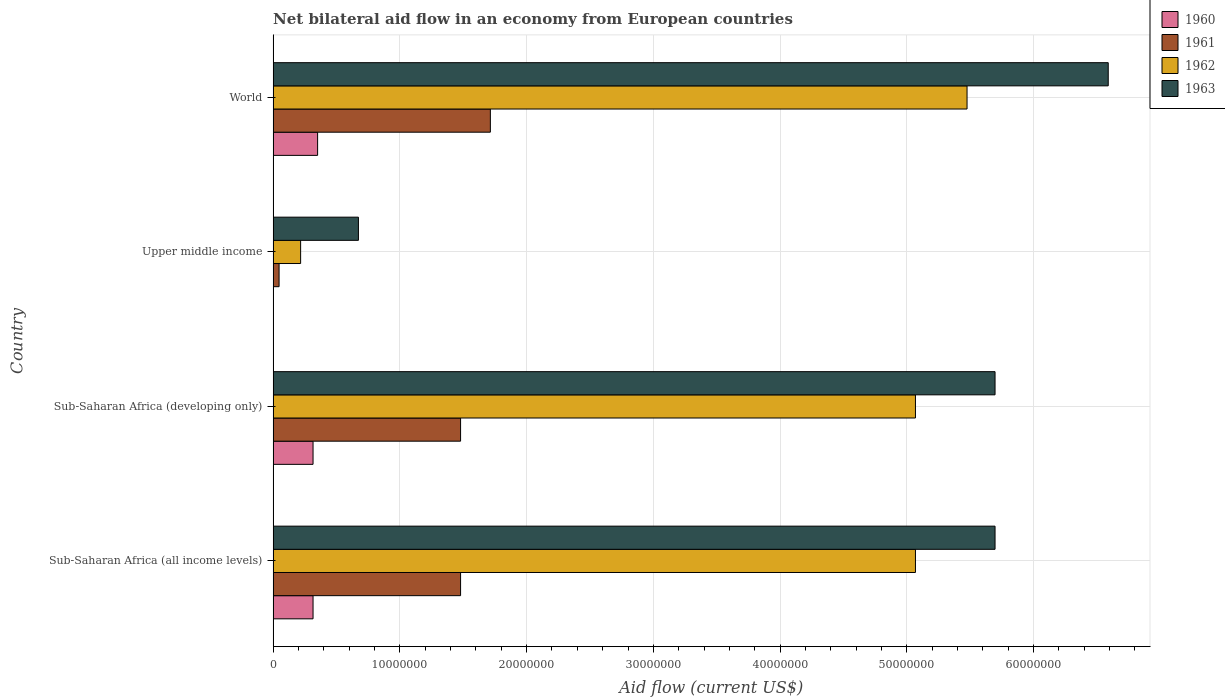How many different coloured bars are there?
Give a very brief answer. 4. How many groups of bars are there?
Give a very brief answer. 4. Are the number of bars per tick equal to the number of legend labels?
Provide a short and direct response. Yes. Are the number of bars on each tick of the Y-axis equal?
Offer a terse response. Yes. How many bars are there on the 4th tick from the top?
Offer a very short reply. 4. How many bars are there on the 4th tick from the bottom?
Ensure brevity in your answer.  4. What is the label of the 3rd group of bars from the top?
Provide a short and direct response. Sub-Saharan Africa (developing only). What is the net bilateral aid flow in 1962 in World?
Provide a succinct answer. 5.48e+07. Across all countries, what is the maximum net bilateral aid flow in 1960?
Your answer should be compact. 3.51e+06. In which country was the net bilateral aid flow in 1960 maximum?
Keep it short and to the point. World. In which country was the net bilateral aid flow in 1962 minimum?
Your answer should be compact. Upper middle income. What is the total net bilateral aid flow in 1961 in the graph?
Provide a succinct answer. 4.72e+07. What is the difference between the net bilateral aid flow in 1961 in Sub-Saharan Africa (all income levels) and that in Upper middle income?
Make the answer very short. 1.43e+07. What is the difference between the net bilateral aid flow in 1963 in Sub-Saharan Africa (developing only) and the net bilateral aid flow in 1962 in Upper middle income?
Your answer should be very brief. 5.48e+07. What is the average net bilateral aid flow in 1960 per country?
Keep it short and to the point. 2.46e+06. What is the difference between the net bilateral aid flow in 1960 and net bilateral aid flow in 1962 in World?
Ensure brevity in your answer.  -5.12e+07. In how many countries, is the net bilateral aid flow in 1961 greater than 24000000 US$?
Ensure brevity in your answer.  0. What is the ratio of the net bilateral aid flow in 1961 in Sub-Saharan Africa (developing only) to that in World?
Make the answer very short. 0.86. Is the difference between the net bilateral aid flow in 1960 in Sub-Saharan Africa (developing only) and World greater than the difference between the net bilateral aid flow in 1962 in Sub-Saharan Africa (developing only) and World?
Ensure brevity in your answer.  Yes. What is the difference between the highest and the second highest net bilateral aid flow in 1961?
Ensure brevity in your answer.  2.35e+06. What is the difference between the highest and the lowest net bilateral aid flow in 1962?
Your answer should be very brief. 5.26e+07. In how many countries, is the net bilateral aid flow in 1963 greater than the average net bilateral aid flow in 1963 taken over all countries?
Your answer should be compact. 3. Is it the case that in every country, the sum of the net bilateral aid flow in 1960 and net bilateral aid flow in 1963 is greater than the sum of net bilateral aid flow in 1961 and net bilateral aid flow in 1962?
Your answer should be very brief. No. What does the 2nd bar from the top in World represents?
Your response must be concise. 1962. Is it the case that in every country, the sum of the net bilateral aid flow in 1962 and net bilateral aid flow in 1963 is greater than the net bilateral aid flow in 1961?
Your answer should be compact. Yes. What is the difference between two consecutive major ticks on the X-axis?
Give a very brief answer. 1.00e+07. Are the values on the major ticks of X-axis written in scientific E-notation?
Your answer should be compact. No. Does the graph contain any zero values?
Your answer should be very brief. No. Where does the legend appear in the graph?
Keep it short and to the point. Top right. How many legend labels are there?
Your response must be concise. 4. What is the title of the graph?
Give a very brief answer. Net bilateral aid flow in an economy from European countries. What is the label or title of the X-axis?
Your answer should be compact. Aid flow (current US$). What is the label or title of the Y-axis?
Your answer should be compact. Country. What is the Aid flow (current US$) of 1960 in Sub-Saharan Africa (all income levels)?
Offer a very short reply. 3.15e+06. What is the Aid flow (current US$) in 1961 in Sub-Saharan Africa (all income levels)?
Offer a very short reply. 1.48e+07. What is the Aid flow (current US$) in 1962 in Sub-Saharan Africa (all income levels)?
Your answer should be very brief. 5.07e+07. What is the Aid flow (current US$) in 1963 in Sub-Saharan Africa (all income levels)?
Give a very brief answer. 5.70e+07. What is the Aid flow (current US$) in 1960 in Sub-Saharan Africa (developing only)?
Offer a terse response. 3.15e+06. What is the Aid flow (current US$) of 1961 in Sub-Saharan Africa (developing only)?
Make the answer very short. 1.48e+07. What is the Aid flow (current US$) of 1962 in Sub-Saharan Africa (developing only)?
Offer a very short reply. 5.07e+07. What is the Aid flow (current US$) of 1963 in Sub-Saharan Africa (developing only)?
Keep it short and to the point. 5.70e+07. What is the Aid flow (current US$) in 1960 in Upper middle income?
Your answer should be very brief. 10000. What is the Aid flow (current US$) of 1962 in Upper middle income?
Your answer should be very brief. 2.17e+06. What is the Aid flow (current US$) in 1963 in Upper middle income?
Your answer should be compact. 6.73e+06. What is the Aid flow (current US$) in 1960 in World?
Provide a succinct answer. 3.51e+06. What is the Aid flow (current US$) of 1961 in World?
Keep it short and to the point. 1.71e+07. What is the Aid flow (current US$) in 1962 in World?
Give a very brief answer. 5.48e+07. What is the Aid flow (current US$) in 1963 in World?
Your response must be concise. 6.59e+07. Across all countries, what is the maximum Aid flow (current US$) of 1960?
Make the answer very short. 3.51e+06. Across all countries, what is the maximum Aid flow (current US$) in 1961?
Provide a succinct answer. 1.71e+07. Across all countries, what is the maximum Aid flow (current US$) in 1962?
Provide a succinct answer. 5.48e+07. Across all countries, what is the maximum Aid flow (current US$) in 1963?
Ensure brevity in your answer.  6.59e+07. Across all countries, what is the minimum Aid flow (current US$) of 1961?
Offer a terse response. 4.70e+05. Across all countries, what is the minimum Aid flow (current US$) of 1962?
Keep it short and to the point. 2.17e+06. Across all countries, what is the minimum Aid flow (current US$) in 1963?
Ensure brevity in your answer.  6.73e+06. What is the total Aid flow (current US$) of 1960 in the graph?
Ensure brevity in your answer.  9.82e+06. What is the total Aid flow (current US$) in 1961 in the graph?
Your answer should be very brief. 4.72e+07. What is the total Aid flow (current US$) in 1962 in the graph?
Provide a short and direct response. 1.58e+08. What is the total Aid flow (current US$) of 1963 in the graph?
Provide a short and direct response. 1.87e+08. What is the difference between the Aid flow (current US$) of 1960 in Sub-Saharan Africa (all income levels) and that in Sub-Saharan Africa (developing only)?
Ensure brevity in your answer.  0. What is the difference between the Aid flow (current US$) of 1961 in Sub-Saharan Africa (all income levels) and that in Sub-Saharan Africa (developing only)?
Offer a terse response. 0. What is the difference between the Aid flow (current US$) of 1963 in Sub-Saharan Africa (all income levels) and that in Sub-Saharan Africa (developing only)?
Provide a short and direct response. 0. What is the difference between the Aid flow (current US$) in 1960 in Sub-Saharan Africa (all income levels) and that in Upper middle income?
Give a very brief answer. 3.14e+06. What is the difference between the Aid flow (current US$) in 1961 in Sub-Saharan Africa (all income levels) and that in Upper middle income?
Ensure brevity in your answer.  1.43e+07. What is the difference between the Aid flow (current US$) of 1962 in Sub-Saharan Africa (all income levels) and that in Upper middle income?
Ensure brevity in your answer.  4.85e+07. What is the difference between the Aid flow (current US$) in 1963 in Sub-Saharan Africa (all income levels) and that in Upper middle income?
Your response must be concise. 5.02e+07. What is the difference between the Aid flow (current US$) in 1960 in Sub-Saharan Africa (all income levels) and that in World?
Offer a very short reply. -3.60e+05. What is the difference between the Aid flow (current US$) in 1961 in Sub-Saharan Africa (all income levels) and that in World?
Your answer should be compact. -2.35e+06. What is the difference between the Aid flow (current US$) in 1962 in Sub-Saharan Africa (all income levels) and that in World?
Provide a short and direct response. -4.07e+06. What is the difference between the Aid flow (current US$) of 1963 in Sub-Saharan Africa (all income levels) and that in World?
Make the answer very short. -8.93e+06. What is the difference between the Aid flow (current US$) in 1960 in Sub-Saharan Africa (developing only) and that in Upper middle income?
Your answer should be very brief. 3.14e+06. What is the difference between the Aid flow (current US$) in 1961 in Sub-Saharan Africa (developing only) and that in Upper middle income?
Offer a very short reply. 1.43e+07. What is the difference between the Aid flow (current US$) of 1962 in Sub-Saharan Africa (developing only) and that in Upper middle income?
Your answer should be compact. 4.85e+07. What is the difference between the Aid flow (current US$) of 1963 in Sub-Saharan Africa (developing only) and that in Upper middle income?
Your answer should be very brief. 5.02e+07. What is the difference between the Aid flow (current US$) of 1960 in Sub-Saharan Africa (developing only) and that in World?
Your answer should be compact. -3.60e+05. What is the difference between the Aid flow (current US$) of 1961 in Sub-Saharan Africa (developing only) and that in World?
Offer a very short reply. -2.35e+06. What is the difference between the Aid flow (current US$) in 1962 in Sub-Saharan Africa (developing only) and that in World?
Make the answer very short. -4.07e+06. What is the difference between the Aid flow (current US$) of 1963 in Sub-Saharan Africa (developing only) and that in World?
Your answer should be very brief. -8.93e+06. What is the difference between the Aid flow (current US$) of 1960 in Upper middle income and that in World?
Ensure brevity in your answer.  -3.50e+06. What is the difference between the Aid flow (current US$) of 1961 in Upper middle income and that in World?
Provide a succinct answer. -1.67e+07. What is the difference between the Aid flow (current US$) in 1962 in Upper middle income and that in World?
Give a very brief answer. -5.26e+07. What is the difference between the Aid flow (current US$) in 1963 in Upper middle income and that in World?
Your response must be concise. -5.92e+07. What is the difference between the Aid flow (current US$) of 1960 in Sub-Saharan Africa (all income levels) and the Aid flow (current US$) of 1961 in Sub-Saharan Africa (developing only)?
Give a very brief answer. -1.16e+07. What is the difference between the Aid flow (current US$) of 1960 in Sub-Saharan Africa (all income levels) and the Aid flow (current US$) of 1962 in Sub-Saharan Africa (developing only)?
Keep it short and to the point. -4.75e+07. What is the difference between the Aid flow (current US$) in 1960 in Sub-Saharan Africa (all income levels) and the Aid flow (current US$) in 1963 in Sub-Saharan Africa (developing only)?
Your response must be concise. -5.38e+07. What is the difference between the Aid flow (current US$) in 1961 in Sub-Saharan Africa (all income levels) and the Aid flow (current US$) in 1962 in Sub-Saharan Africa (developing only)?
Provide a succinct answer. -3.59e+07. What is the difference between the Aid flow (current US$) of 1961 in Sub-Saharan Africa (all income levels) and the Aid flow (current US$) of 1963 in Sub-Saharan Africa (developing only)?
Offer a terse response. -4.22e+07. What is the difference between the Aid flow (current US$) in 1962 in Sub-Saharan Africa (all income levels) and the Aid flow (current US$) in 1963 in Sub-Saharan Africa (developing only)?
Offer a terse response. -6.28e+06. What is the difference between the Aid flow (current US$) in 1960 in Sub-Saharan Africa (all income levels) and the Aid flow (current US$) in 1961 in Upper middle income?
Make the answer very short. 2.68e+06. What is the difference between the Aid flow (current US$) of 1960 in Sub-Saharan Africa (all income levels) and the Aid flow (current US$) of 1962 in Upper middle income?
Ensure brevity in your answer.  9.80e+05. What is the difference between the Aid flow (current US$) of 1960 in Sub-Saharan Africa (all income levels) and the Aid flow (current US$) of 1963 in Upper middle income?
Provide a short and direct response. -3.58e+06. What is the difference between the Aid flow (current US$) in 1961 in Sub-Saharan Africa (all income levels) and the Aid flow (current US$) in 1962 in Upper middle income?
Provide a short and direct response. 1.26e+07. What is the difference between the Aid flow (current US$) in 1961 in Sub-Saharan Africa (all income levels) and the Aid flow (current US$) in 1963 in Upper middle income?
Your answer should be compact. 8.06e+06. What is the difference between the Aid flow (current US$) in 1962 in Sub-Saharan Africa (all income levels) and the Aid flow (current US$) in 1963 in Upper middle income?
Your response must be concise. 4.40e+07. What is the difference between the Aid flow (current US$) in 1960 in Sub-Saharan Africa (all income levels) and the Aid flow (current US$) in 1961 in World?
Make the answer very short. -1.40e+07. What is the difference between the Aid flow (current US$) in 1960 in Sub-Saharan Africa (all income levels) and the Aid flow (current US$) in 1962 in World?
Your answer should be compact. -5.16e+07. What is the difference between the Aid flow (current US$) of 1960 in Sub-Saharan Africa (all income levels) and the Aid flow (current US$) of 1963 in World?
Offer a terse response. -6.27e+07. What is the difference between the Aid flow (current US$) of 1961 in Sub-Saharan Africa (all income levels) and the Aid flow (current US$) of 1962 in World?
Your answer should be very brief. -4.00e+07. What is the difference between the Aid flow (current US$) in 1961 in Sub-Saharan Africa (all income levels) and the Aid flow (current US$) in 1963 in World?
Keep it short and to the point. -5.11e+07. What is the difference between the Aid flow (current US$) of 1962 in Sub-Saharan Africa (all income levels) and the Aid flow (current US$) of 1963 in World?
Offer a very short reply. -1.52e+07. What is the difference between the Aid flow (current US$) in 1960 in Sub-Saharan Africa (developing only) and the Aid flow (current US$) in 1961 in Upper middle income?
Offer a terse response. 2.68e+06. What is the difference between the Aid flow (current US$) in 1960 in Sub-Saharan Africa (developing only) and the Aid flow (current US$) in 1962 in Upper middle income?
Provide a short and direct response. 9.80e+05. What is the difference between the Aid flow (current US$) of 1960 in Sub-Saharan Africa (developing only) and the Aid flow (current US$) of 1963 in Upper middle income?
Provide a short and direct response. -3.58e+06. What is the difference between the Aid flow (current US$) in 1961 in Sub-Saharan Africa (developing only) and the Aid flow (current US$) in 1962 in Upper middle income?
Ensure brevity in your answer.  1.26e+07. What is the difference between the Aid flow (current US$) in 1961 in Sub-Saharan Africa (developing only) and the Aid flow (current US$) in 1963 in Upper middle income?
Ensure brevity in your answer.  8.06e+06. What is the difference between the Aid flow (current US$) of 1962 in Sub-Saharan Africa (developing only) and the Aid flow (current US$) of 1963 in Upper middle income?
Give a very brief answer. 4.40e+07. What is the difference between the Aid flow (current US$) of 1960 in Sub-Saharan Africa (developing only) and the Aid flow (current US$) of 1961 in World?
Your answer should be very brief. -1.40e+07. What is the difference between the Aid flow (current US$) in 1960 in Sub-Saharan Africa (developing only) and the Aid flow (current US$) in 1962 in World?
Offer a terse response. -5.16e+07. What is the difference between the Aid flow (current US$) in 1960 in Sub-Saharan Africa (developing only) and the Aid flow (current US$) in 1963 in World?
Ensure brevity in your answer.  -6.27e+07. What is the difference between the Aid flow (current US$) of 1961 in Sub-Saharan Africa (developing only) and the Aid flow (current US$) of 1962 in World?
Give a very brief answer. -4.00e+07. What is the difference between the Aid flow (current US$) of 1961 in Sub-Saharan Africa (developing only) and the Aid flow (current US$) of 1963 in World?
Offer a very short reply. -5.11e+07. What is the difference between the Aid flow (current US$) of 1962 in Sub-Saharan Africa (developing only) and the Aid flow (current US$) of 1963 in World?
Give a very brief answer. -1.52e+07. What is the difference between the Aid flow (current US$) of 1960 in Upper middle income and the Aid flow (current US$) of 1961 in World?
Offer a very short reply. -1.71e+07. What is the difference between the Aid flow (current US$) of 1960 in Upper middle income and the Aid flow (current US$) of 1962 in World?
Make the answer very short. -5.47e+07. What is the difference between the Aid flow (current US$) of 1960 in Upper middle income and the Aid flow (current US$) of 1963 in World?
Offer a terse response. -6.59e+07. What is the difference between the Aid flow (current US$) of 1961 in Upper middle income and the Aid flow (current US$) of 1962 in World?
Provide a succinct answer. -5.43e+07. What is the difference between the Aid flow (current US$) in 1961 in Upper middle income and the Aid flow (current US$) in 1963 in World?
Your response must be concise. -6.54e+07. What is the difference between the Aid flow (current US$) in 1962 in Upper middle income and the Aid flow (current US$) in 1963 in World?
Provide a short and direct response. -6.37e+07. What is the average Aid flow (current US$) in 1960 per country?
Make the answer very short. 2.46e+06. What is the average Aid flow (current US$) in 1961 per country?
Provide a succinct answer. 1.18e+07. What is the average Aid flow (current US$) of 1962 per country?
Give a very brief answer. 3.96e+07. What is the average Aid flow (current US$) of 1963 per country?
Offer a very short reply. 4.66e+07. What is the difference between the Aid flow (current US$) of 1960 and Aid flow (current US$) of 1961 in Sub-Saharan Africa (all income levels)?
Your answer should be very brief. -1.16e+07. What is the difference between the Aid flow (current US$) in 1960 and Aid flow (current US$) in 1962 in Sub-Saharan Africa (all income levels)?
Ensure brevity in your answer.  -4.75e+07. What is the difference between the Aid flow (current US$) in 1960 and Aid flow (current US$) in 1963 in Sub-Saharan Africa (all income levels)?
Provide a short and direct response. -5.38e+07. What is the difference between the Aid flow (current US$) of 1961 and Aid flow (current US$) of 1962 in Sub-Saharan Africa (all income levels)?
Make the answer very short. -3.59e+07. What is the difference between the Aid flow (current US$) in 1961 and Aid flow (current US$) in 1963 in Sub-Saharan Africa (all income levels)?
Your response must be concise. -4.22e+07. What is the difference between the Aid flow (current US$) of 1962 and Aid flow (current US$) of 1963 in Sub-Saharan Africa (all income levels)?
Your answer should be very brief. -6.28e+06. What is the difference between the Aid flow (current US$) of 1960 and Aid flow (current US$) of 1961 in Sub-Saharan Africa (developing only)?
Your response must be concise. -1.16e+07. What is the difference between the Aid flow (current US$) in 1960 and Aid flow (current US$) in 1962 in Sub-Saharan Africa (developing only)?
Offer a very short reply. -4.75e+07. What is the difference between the Aid flow (current US$) of 1960 and Aid flow (current US$) of 1963 in Sub-Saharan Africa (developing only)?
Keep it short and to the point. -5.38e+07. What is the difference between the Aid flow (current US$) in 1961 and Aid flow (current US$) in 1962 in Sub-Saharan Africa (developing only)?
Keep it short and to the point. -3.59e+07. What is the difference between the Aid flow (current US$) of 1961 and Aid flow (current US$) of 1963 in Sub-Saharan Africa (developing only)?
Offer a terse response. -4.22e+07. What is the difference between the Aid flow (current US$) of 1962 and Aid flow (current US$) of 1963 in Sub-Saharan Africa (developing only)?
Ensure brevity in your answer.  -6.28e+06. What is the difference between the Aid flow (current US$) in 1960 and Aid flow (current US$) in 1961 in Upper middle income?
Make the answer very short. -4.60e+05. What is the difference between the Aid flow (current US$) in 1960 and Aid flow (current US$) in 1962 in Upper middle income?
Your answer should be very brief. -2.16e+06. What is the difference between the Aid flow (current US$) in 1960 and Aid flow (current US$) in 1963 in Upper middle income?
Keep it short and to the point. -6.72e+06. What is the difference between the Aid flow (current US$) of 1961 and Aid flow (current US$) of 1962 in Upper middle income?
Offer a terse response. -1.70e+06. What is the difference between the Aid flow (current US$) of 1961 and Aid flow (current US$) of 1963 in Upper middle income?
Ensure brevity in your answer.  -6.26e+06. What is the difference between the Aid flow (current US$) of 1962 and Aid flow (current US$) of 1963 in Upper middle income?
Ensure brevity in your answer.  -4.56e+06. What is the difference between the Aid flow (current US$) in 1960 and Aid flow (current US$) in 1961 in World?
Keep it short and to the point. -1.36e+07. What is the difference between the Aid flow (current US$) in 1960 and Aid flow (current US$) in 1962 in World?
Provide a short and direct response. -5.12e+07. What is the difference between the Aid flow (current US$) in 1960 and Aid flow (current US$) in 1963 in World?
Offer a terse response. -6.24e+07. What is the difference between the Aid flow (current US$) of 1961 and Aid flow (current US$) of 1962 in World?
Offer a terse response. -3.76e+07. What is the difference between the Aid flow (current US$) of 1961 and Aid flow (current US$) of 1963 in World?
Make the answer very short. -4.88e+07. What is the difference between the Aid flow (current US$) in 1962 and Aid flow (current US$) in 1963 in World?
Provide a short and direct response. -1.11e+07. What is the ratio of the Aid flow (current US$) in 1960 in Sub-Saharan Africa (all income levels) to that in Sub-Saharan Africa (developing only)?
Keep it short and to the point. 1. What is the ratio of the Aid flow (current US$) of 1961 in Sub-Saharan Africa (all income levels) to that in Sub-Saharan Africa (developing only)?
Your answer should be very brief. 1. What is the ratio of the Aid flow (current US$) of 1962 in Sub-Saharan Africa (all income levels) to that in Sub-Saharan Africa (developing only)?
Give a very brief answer. 1. What is the ratio of the Aid flow (current US$) in 1963 in Sub-Saharan Africa (all income levels) to that in Sub-Saharan Africa (developing only)?
Keep it short and to the point. 1. What is the ratio of the Aid flow (current US$) of 1960 in Sub-Saharan Africa (all income levels) to that in Upper middle income?
Provide a succinct answer. 315. What is the ratio of the Aid flow (current US$) in 1961 in Sub-Saharan Africa (all income levels) to that in Upper middle income?
Offer a terse response. 31.47. What is the ratio of the Aid flow (current US$) of 1962 in Sub-Saharan Africa (all income levels) to that in Upper middle income?
Keep it short and to the point. 23.35. What is the ratio of the Aid flow (current US$) of 1963 in Sub-Saharan Africa (all income levels) to that in Upper middle income?
Your answer should be very brief. 8.46. What is the ratio of the Aid flow (current US$) of 1960 in Sub-Saharan Africa (all income levels) to that in World?
Offer a terse response. 0.9. What is the ratio of the Aid flow (current US$) of 1961 in Sub-Saharan Africa (all income levels) to that in World?
Offer a very short reply. 0.86. What is the ratio of the Aid flow (current US$) in 1962 in Sub-Saharan Africa (all income levels) to that in World?
Provide a short and direct response. 0.93. What is the ratio of the Aid flow (current US$) of 1963 in Sub-Saharan Africa (all income levels) to that in World?
Ensure brevity in your answer.  0.86. What is the ratio of the Aid flow (current US$) in 1960 in Sub-Saharan Africa (developing only) to that in Upper middle income?
Keep it short and to the point. 315. What is the ratio of the Aid flow (current US$) in 1961 in Sub-Saharan Africa (developing only) to that in Upper middle income?
Give a very brief answer. 31.47. What is the ratio of the Aid flow (current US$) in 1962 in Sub-Saharan Africa (developing only) to that in Upper middle income?
Provide a short and direct response. 23.35. What is the ratio of the Aid flow (current US$) in 1963 in Sub-Saharan Africa (developing only) to that in Upper middle income?
Keep it short and to the point. 8.46. What is the ratio of the Aid flow (current US$) in 1960 in Sub-Saharan Africa (developing only) to that in World?
Ensure brevity in your answer.  0.9. What is the ratio of the Aid flow (current US$) of 1961 in Sub-Saharan Africa (developing only) to that in World?
Your answer should be compact. 0.86. What is the ratio of the Aid flow (current US$) of 1962 in Sub-Saharan Africa (developing only) to that in World?
Offer a terse response. 0.93. What is the ratio of the Aid flow (current US$) in 1963 in Sub-Saharan Africa (developing only) to that in World?
Offer a very short reply. 0.86. What is the ratio of the Aid flow (current US$) in 1960 in Upper middle income to that in World?
Provide a succinct answer. 0. What is the ratio of the Aid flow (current US$) of 1961 in Upper middle income to that in World?
Ensure brevity in your answer.  0.03. What is the ratio of the Aid flow (current US$) of 1962 in Upper middle income to that in World?
Your response must be concise. 0.04. What is the ratio of the Aid flow (current US$) in 1963 in Upper middle income to that in World?
Offer a very short reply. 0.1. What is the difference between the highest and the second highest Aid flow (current US$) in 1960?
Ensure brevity in your answer.  3.60e+05. What is the difference between the highest and the second highest Aid flow (current US$) of 1961?
Offer a very short reply. 2.35e+06. What is the difference between the highest and the second highest Aid flow (current US$) in 1962?
Provide a succinct answer. 4.07e+06. What is the difference between the highest and the second highest Aid flow (current US$) of 1963?
Provide a succinct answer. 8.93e+06. What is the difference between the highest and the lowest Aid flow (current US$) of 1960?
Provide a succinct answer. 3.50e+06. What is the difference between the highest and the lowest Aid flow (current US$) in 1961?
Make the answer very short. 1.67e+07. What is the difference between the highest and the lowest Aid flow (current US$) in 1962?
Offer a terse response. 5.26e+07. What is the difference between the highest and the lowest Aid flow (current US$) of 1963?
Provide a short and direct response. 5.92e+07. 